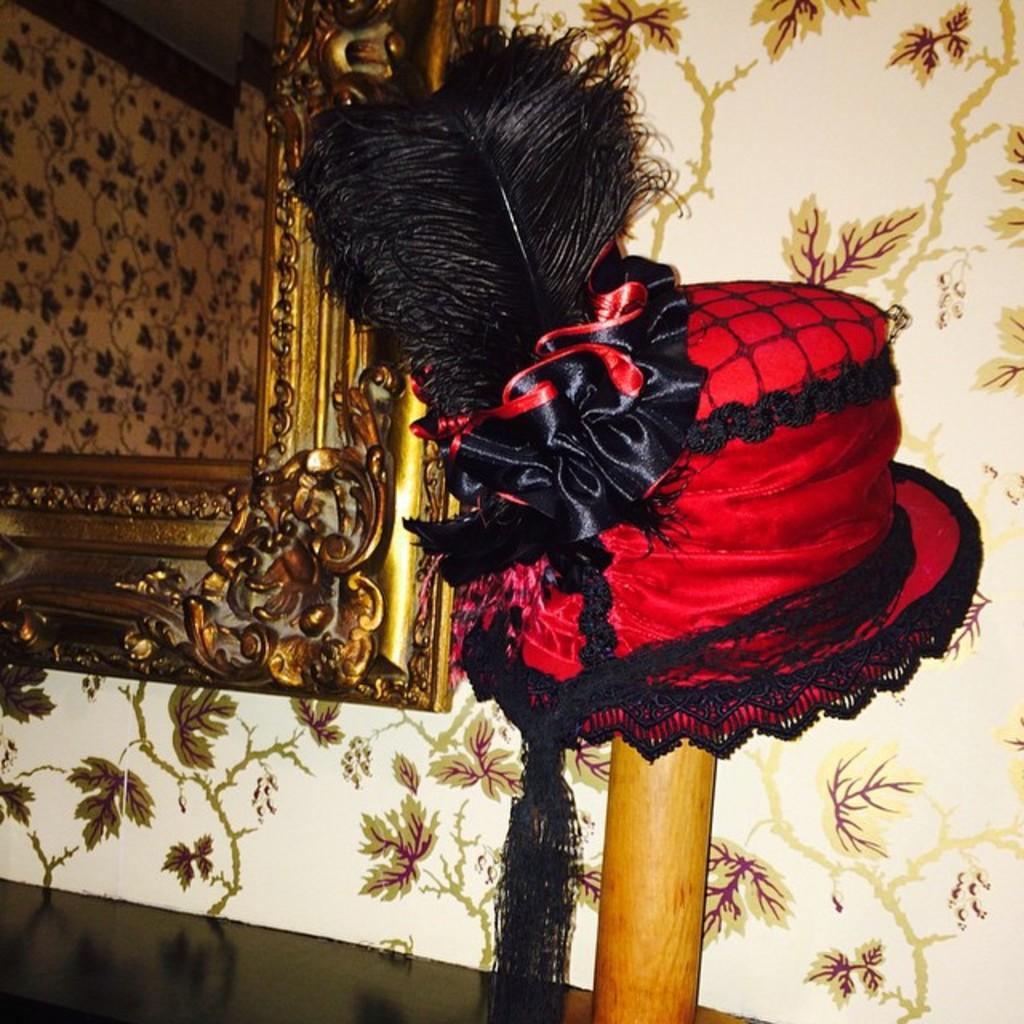What object can be seen on a stick in the image? There is a hat on a stick in the image. What is located at the bottom of the image? There is a table at the bottom of the image. Where is the mirror positioned in the image? The mirror is in the top left corner of the image. How is the mirror attached to the wall? The mirror is hung on a wall. What type of oatmeal is being served on the table in the image? There is no oatmeal present in the image; the table is empty. What shape is the crow in the image? There is no crow present in the image. 